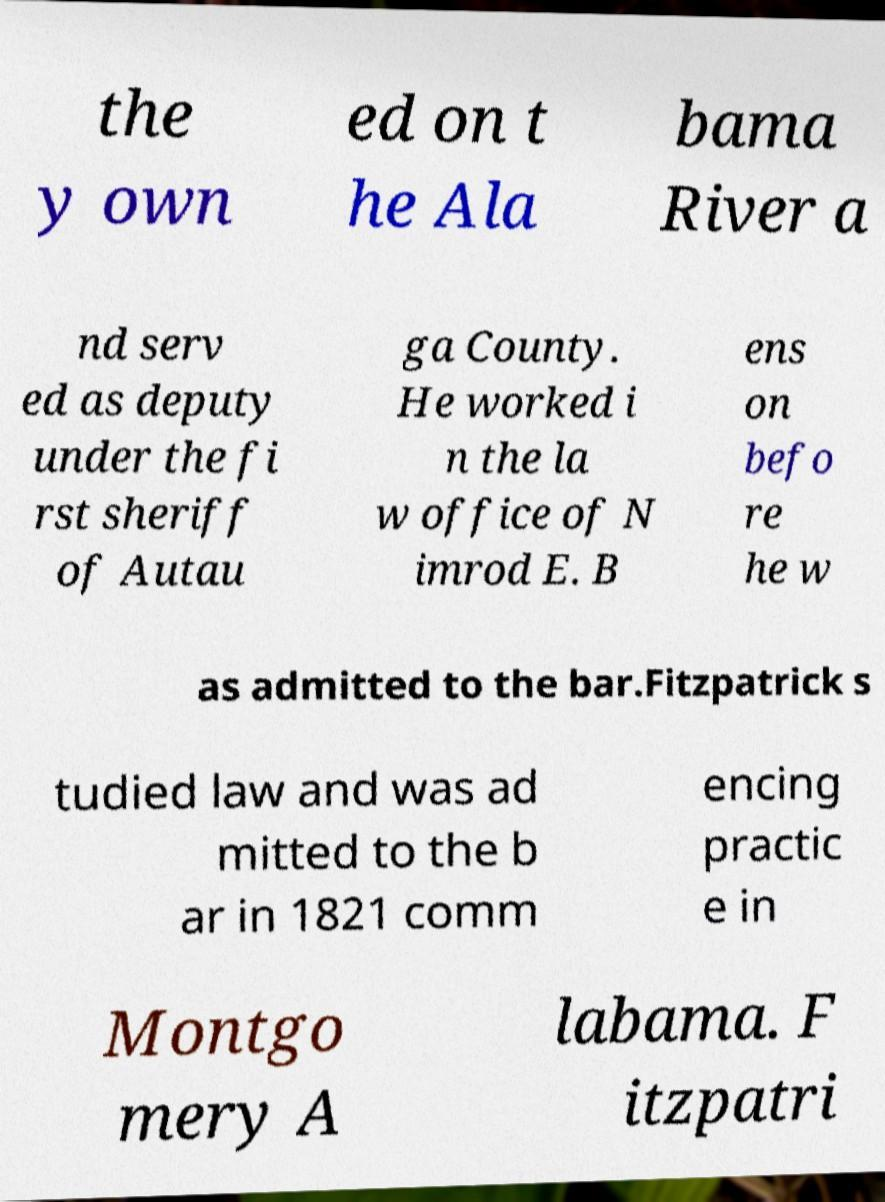Can you read and provide the text displayed in the image?This photo seems to have some interesting text. Can you extract and type it out for me? the y own ed on t he Ala bama River a nd serv ed as deputy under the fi rst sheriff of Autau ga County. He worked i n the la w office of N imrod E. B ens on befo re he w as admitted to the bar.Fitzpatrick s tudied law and was ad mitted to the b ar in 1821 comm encing practic e in Montgo mery A labama. F itzpatri 